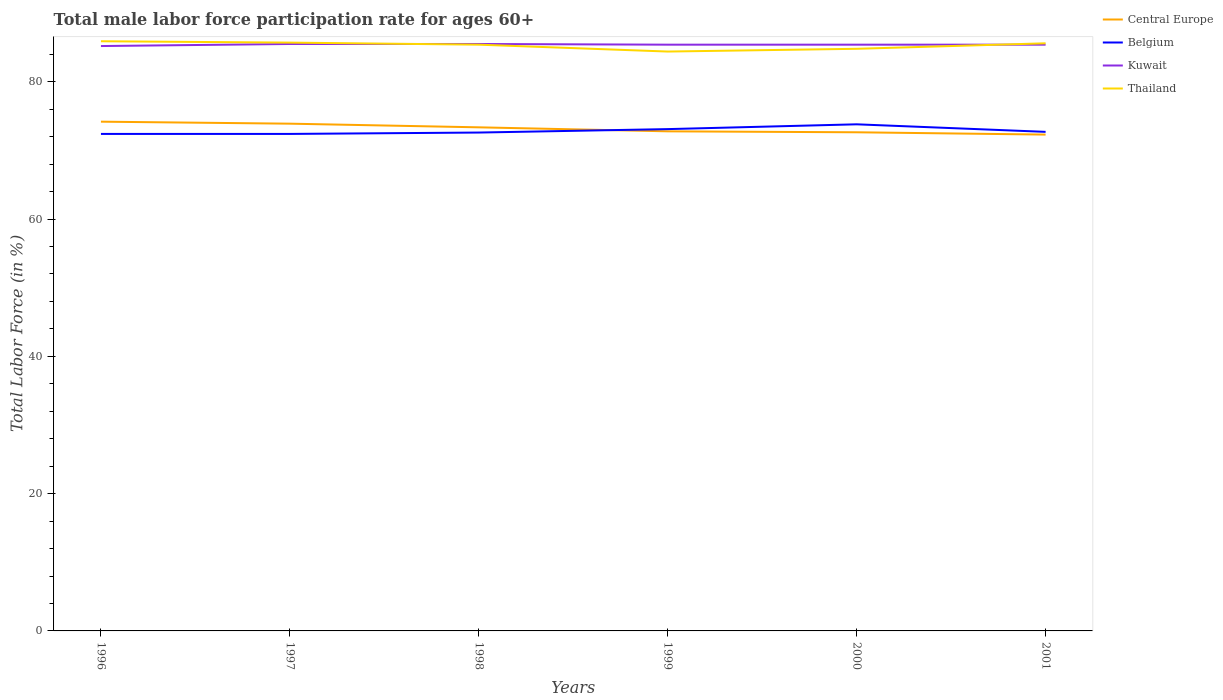How many different coloured lines are there?
Provide a short and direct response. 4. Across all years, what is the maximum male labor force participation rate in Kuwait?
Your answer should be compact. 85.2. In which year was the male labor force participation rate in Kuwait maximum?
Your answer should be very brief. 1996. What is the total male labor force participation rate in Central Europe in the graph?
Your answer should be very brief. 0.14. What is the difference between the highest and the second highest male labor force participation rate in Central Europe?
Your answer should be very brief. 1.88. Is the male labor force participation rate in Central Europe strictly greater than the male labor force participation rate in Kuwait over the years?
Ensure brevity in your answer.  Yes. Are the values on the major ticks of Y-axis written in scientific E-notation?
Your response must be concise. No. Does the graph contain any zero values?
Give a very brief answer. No. Does the graph contain grids?
Provide a short and direct response. No. How many legend labels are there?
Keep it short and to the point. 4. How are the legend labels stacked?
Provide a succinct answer. Vertical. What is the title of the graph?
Your response must be concise. Total male labor force participation rate for ages 60+. Does "Greece" appear as one of the legend labels in the graph?
Provide a succinct answer. No. What is the label or title of the X-axis?
Give a very brief answer. Years. What is the label or title of the Y-axis?
Give a very brief answer. Total Labor Force (in %). What is the Total Labor Force (in %) in Central Europe in 1996?
Keep it short and to the point. 74.18. What is the Total Labor Force (in %) in Belgium in 1996?
Provide a succinct answer. 72.4. What is the Total Labor Force (in %) in Kuwait in 1996?
Offer a terse response. 85.2. What is the Total Labor Force (in %) of Thailand in 1996?
Keep it short and to the point. 85.9. What is the Total Labor Force (in %) of Central Europe in 1997?
Your answer should be compact. 73.89. What is the Total Labor Force (in %) in Belgium in 1997?
Keep it short and to the point. 72.4. What is the Total Labor Force (in %) in Kuwait in 1997?
Ensure brevity in your answer.  85.5. What is the Total Labor Force (in %) of Thailand in 1997?
Provide a short and direct response. 85.7. What is the Total Labor Force (in %) in Central Europe in 1998?
Offer a very short reply. 73.36. What is the Total Labor Force (in %) of Belgium in 1998?
Keep it short and to the point. 72.6. What is the Total Labor Force (in %) in Kuwait in 1998?
Your answer should be compact. 85.5. What is the Total Labor Force (in %) of Thailand in 1998?
Offer a terse response. 85.4. What is the Total Labor Force (in %) in Central Europe in 1999?
Make the answer very short. 72.78. What is the Total Labor Force (in %) of Belgium in 1999?
Ensure brevity in your answer.  73.1. What is the Total Labor Force (in %) in Kuwait in 1999?
Give a very brief answer. 85.4. What is the Total Labor Force (in %) of Thailand in 1999?
Provide a short and direct response. 84.4. What is the Total Labor Force (in %) in Central Europe in 2000?
Give a very brief answer. 72.64. What is the Total Labor Force (in %) of Belgium in 2000?
Your response must be concise. 73.8. What is the Total Labor Force (in %) of Kuwait in 2000?
Ensure brevity in your answer.  85.4. What is the Total Labor Force (in %) of Thailand in 2000?
Your answer should be very brief. 84.8. What is the Total Labor Force (in %) in Central Europe in 2001?
Your answer should be very brief. 72.3. What is the Total Labor Force (in %) in Belgium in 2001?
Your answer should be compact. 72.7. What is the Total Labor Force (in %) of Kuwait in 2001?
Your answer should be very brief. 85.4. What is the Total Labor Force (in %) in Thailand in 2001?
Offer a very short reply. 85.6. Across all years, what is the maximum Total Labor Force (in %) in Central Europe?
Ensure brevity in your answer.  74.18. Across all years, what is the maximum Total Labor Force (in %) in Belgium?
Offer a very short reply. 73.8. Across all years, what is the maximum Total Labor Force (in %) of Kuwait?
Keep it short and to the point. 85.5. Across all years, what is the maximum Total Labor Force (in %) in Thailand?
Offer a terse response. 85.9. Across all years, what is the minimum Total Labor Force (in %) of Central Europe?
Offer a very short reply. 72.3. Across all years, what is the minimum Total Labor Force (in %) in Belgium?
Give a very brief answer. 72.4. Across all years, what is the minimum Total Labor Force (in %) of Kuwait?
Offer a very short reply. 85.2. Across all years, what is the minimum Total Labor Force (in %) in Thailand?
Your answer should be very brief. 84.4. What is the total Total Labor Force (in %) of Central Europe in the graph?
Offer a very short reply. 439.15. What is the total Total Labor Force (in %) of Belgium in the graph?
Your response must be concise. 437. What is the total Total Labor Force (in %) of Kuwait in the graph?
Give a very brief answer. 512.4. What is the total Total Labor Force (in %) in Thailand in the graph?
Your answer should be very brief. 511.8. What is the difference between the Total Labor Force (in %) in Central Europe in 1996 and that in 1997?
Provide a succinct answer. 0.29. What is the difference between the Total Labor Force (in %) in Central Europe in 1996 and that in 1998?
Offer a terse response. 0.82. What is the difference between the Total Labor Force (in %) in Belgium in 1996 and that in 1998?
Your answer should be compact. -0.2. What is the difference between the Total Labor Force (in %) of Thailand in 1996 and that in 1998?
Your answer should be compact. 0.5. What is the difference between the Total Labor Force (in %) of Central Europe in 1996 and that in 1999?
Your answer should be very brief. 1.41. What is the difference between the Total Labor Force (in %) of Belgium in 1996 and that in 1999?
Offer a terse response. -0.7. What is the difference between the Total Labor Force (in %) in Central Europe in 1996 and that in 2000?
Your answer should be very brief. 1.54. What is the difference between the Total Labor Force (in %) of Belgium in 1996 and that in 2000?
Make the answer very short. -1.4. What is the difference between the Total Labor Force (in %) in Thailand in 1996 and that in 2000?
Give a very brief answer. 1.1. What is the difference between the Total Labor Force (in %) in Central Europe in 1996 and that in 2001?
Provide a succinct answer. 1.88. What is the difference between the Total Labor Force (in %) of Belgium in 1996 and that in 2001?
Offer a terse response. -0.3. What is the difference between the Total Labor Force (in %) of Kuwait in 1996 and that in 2001?
Provide a succinct answer. -0.2. What is the difference between the Total Labor Force (in %) in Central Europe in 1997 and that in 1998?
Your answer should be very brief. 0.53. What is the difference between the Total Labor Force (in %) in Kuwait in 1997 and that in 1998?
Keep it short and to the point. 0. What is the difference between the Total Labor Force (in %) in Thailand in 1997 and that in 1998?
Your answer should be compact. 0.3. What is the difference between the Total Labor Force (in %) of Central Europe in 1997 and that in 1999?
Offer a terse response. 1.11. What is the difference between the Total Labor Force (in %) of Belgium in 1997 and that in 1999?
Make the answer very short. -0.7. What is the difference between the Total Labor Force (in %) of Central Europe in 1997 and that in 2000?
Provide a succinct answer. 1.25. What is the difference between the Total Labor Force (in %) in Belgium in 1997 and that in 2000?
Offer a terse response. -1.4. What is the difference between the Total Labor Force (in %) of Kuwait in 1997 and that in 2000?
Offer a terse response. 0.1. What is the difference between the Total Labor Force (in %) of Thailand in 1997 and that in 2000?
Provide a succinct answer. 0.9. What is the difference between the Total Labor Force (in %) of Central Europe in 1997 and that in 2001?
Your answer should be very brief. 1.59. What is the difference between the Total Labor Force (in %) of Belgium in 1997 and that in 2001?
Your answer should be very brief. -0.3. What is the difference between the Total Labor Force (in %) in Kuwait in 1997 and that in 2001?
Make the answer very short. 0.1. What is the difference between the Total Labor Force (in %) in Thailand in 1997 and that in 2001?
Your answer should be very brief. 0.1. What is the difference between the Total Labor Force (in %) in Central Europe in 1998 and that in 1999?
Give a very brief answer. 0.58. What is the difference between the Total Labor Force (in %) of Thailand in 1998 and that in 1999?
Offer a terse response. 1. What is the difference between the Total Labor Force (in %) in Central Europe in 1998 and that in 2000?
Offer a very short reply. 0.72. What is the difference between the Total Labor Force (in %) in Belgium in 1998 and that in 2000?
Provide a succinct answer. -1.2. What is the difference between the Total Labor Force (in %) of Central Europe in 1998 and that in 2001?
Provide a succinct answer. 1.06. What is the difference between the Total Labor Force (in %) in Belgium in 1998 and that in 2001?
Make the answer very short. -0.1. What is the difference between the Total Labor Force (in %) in Kuwait in 1998 and that in 2001?
Provide a short and direct response. 0.1. What is the difference between the Total Labor Force (in %) of Thailand in 1998 and that in 2001?
Give a very brief answer. -0.2. What is the difference between the Total Labor Force (in %) of Central Europe in 1999 and that in 2000?
Offer a terse response. 0.14. What is the difference between the Total Labor Force (in %) of Kuwait in 1999 and that in 2000?
Give a very brief answer. 0. What is the difference between the Total Labor Force (in %) of Central Europe in 1999 and that in 2001?
Provide a short and direct response. 0.48. What is the difference between the Total Labor Force (in %) in Belgium in 1999 and that in 2001?
Ensure brevity in your answer.  0.4. What is the difference between the Total Labor Force (in %) in Thailand in 1999 and that in 2001?
Offer a terse response. -1.2. What is the difference between the Total Labor Force (in %) of Central Europe in 2000 and that in 2001?
Your answer should be compact. 0.34. What is the difference between the Total Labor Force (in %) of Belgium in 2000 and that in 2001?
Offer a terse response. 1.1. What is the difference between the Total Labor Force (in %) of Central Europe in 1996 and the Total Labor Force (in %) of Belgium in 1997?
Your answer should be very brief. 1.78. What is the difference between the Total Labor Force (in %) in Central Europe in 1996 and the Total Labor Force (in %) in Kuwait in 1997?
Make the answer very short. -11.32. What is the difference between the Total Labor Force (in %) of Central Europe in 1996 and the Total Labor Force (in %) of Thailand in 1997?
Your response must be concise. -11.52. What is the difference between the Total Labor Force (in %) of Kuwait in 1996 and the Total Labor Force (in %) of Thailand in 1997?
Offer a terse response. -0.5. What is the difference between the Total Labor Force (in %) of Central Europe in 1996 and the Total Labor Force (in %) of Belgium in 1998?
Provide a short and direct response. 1.58. What is the difference between the Total Labor Force (in %) in Central Europe in 1996 and the Total Labor Force (in %) in Kuwait in 1998?
Give a very brief answer. -11.32. What is the difference between the Total Labor Force (in %) in Central Europe in 1996 and the Total Labor Force (in %) in Thailand in 1998?
Ensure brevity in your answer.  -11.22. What is the difference between the Total Labor Force (in %) in Belgium in 1996 and the Total Labor Force (in %) in Kuwait in 1998?
Make the answer very short. -13.1. What is the difference between the Total Labor Force (in %) of Central Europe in 1996 and the Total Labor Force (in %) of Belgium in 1999?
Your answer should be compact. 1.08. What is the difference between the Total Labor Force (in %) in Central Europe in 1996 and the Total Labor Force (in %) in Kuwait in 1999?
Provide a short and direct response. -11.22. What is the difference between the Total Labor Force (in %) in Central Europe in 1996 and the Total Labor Force (in %) in Thailand in 1999?
Offer a very short reply. -10.22. What is the difference between the Total Labor Force (in %) of Kuwait in 1996 and the Total Labor Force (in %) of Thailand in 1999?
Offer a very short reply. 0.8. What is the difference between the Total Labor Force (in %) in Central Europe in 1996 and the Total Labor Force (in %) in Belgium in 2000?
Your answer should be compact. 0.38. What is the difference between the Total Labor Force (in %) of Central Europe in 1996 and the Total Labor Force (in %) of Kuwait in 2000?
Provide a succinct answer. -11.22. What is the difference between the Total Labor Force (in %) in Central Europe in 1996 and the Total Labor Force (in %) in Thailand in 2000?
Provide a succinct answer. -10.62. What is the difference between the Total Labor Force (in %) of Belgium in 1996 and the Total Labor Force (in %) of Kuwait in 2000?
Ensure brevity in your answer.  -13. What is the difference between the Total Labor Force (in %) of Central Europe in 1996 and the Total Labor Force (in %) of Belgium in 2001?
Offer a terse response. 1.48. What is the difference between the Total Labor Force (in %) in Central Europe in 1996 and the Total Labor Force (in %) in Kuwait in 2001?
Offer a very short reply. -11.22. What is the difference between the Total Labor Force (in %) in Central Europe in 1996 and the Total Labor Force (in %) in Thailand in 2001?
Offer a terse response. -11.42. What is the difference between the Total Labor Force (in %) in Belgium in 1996 and the Total Labor Force (in %) in Kuwait in 2001?
Ensure brevity in your answer.  -13. What is the difference between the Total Labor Force (in %) of Kuwait in 1996 and the Total Labor Force (in %) of Thailand in 2001?
Offer a terse response. -0.4. What is the difference between the Total Labor Force (in %) in Central Europe in 1997 and the Total Labor Force (in %) in Belgium in 1998?
Your answer should be compact. 1.29. What is the difference between the Total Labor Force (in %) in Central Europe in 1997 and the Total Labor Force (in %) in Kuwait in 1998?
Keep it short and to the point. -11.61. What is the difference between the Total Labor Force (in %) in Central Europe in 1997 and the Total Labor Force (in %) in Thailand in 1998?
Offer a very short reply. -11.51. What is the difference between the Total Labor Force (in %) in Belgium in 1997 and the Total Labor Force (in %) in Thailand in 1998?
Ensure brevity in your answer.  -13. What is the difference between the Total Labor Force (in %) in Central Europe in 1997 and the Total Labor Force (in %) in Belgium in 1999?
Your response must be concise. 0.79. What is the difference between the Total Labor Force (in %) of Central Europe in 1997 and the Total Labor Force (in %) of Kuwait in 1999?
Keep it short and to the point. -11.51. What is the difference between the Total Labor Force (in %) of Central Europe in 1997 and the Total Labor Force (in %) of Thailand in 1999?
Your answer should be compact. -10.51. What is the difference between the Total Labor Force (in %) in Belgium in 1997 and the Total Labor Force (in %) in Thailand in 1999?
Make the answer very short. -12. What is the difference between the Total Labor Force (in %) of Central Europe in 1997 and the Total Labor Force (in %) of Belgium in 2000?
Your response must be concise. 0.09. What is the difference between the Total Labor Force (in %) in Central Europe in 1997 and the Total Labor Force (in %) in Kuwait in 2000?
Provide a succinct answer. -11.51. What is the difference between the Total Labor Force (in %) of Central Europe in 1997 and the Total Labor Force (in %) of Thailand in 2000?
Provide a short and direct response. -10.91. What is the difference between the Total Labor Force (in %) in Belgium in 1997 and the Total Labor Force (in %) in Kuwait in 2000?
Provide a short and direct response. -13. What is the difference between the Total Labor Force (in %) in Belgium in 1997 and the Total Labor Force (in %) in Thailand in 2000?
Make the answer very short. -12.4. What is the difference between the Total Labor Force (in %) of Central Europe in 1997 and the Total Labor Force (in %) of Belgium in 2001?
Ensure brevity in your answer.  1.19. What is the difference between the Total Labor Force (in %) in Central Europe in 1997 and the Total Labor Force (in %) in Kuwait in 2001?
Provide a succinct answer. -11.51. What is the difference between the Total Labor Force (in %) in Central Europe in 1997 and the Total Labor Force (in %) in Thailand in 2001?
Give a very brief answer. -11.71. What is the difference between the Total Labor Force (in %) in Central Europe in 1998 and the Total Labor Force (in %) in Belgium in 1999?
Give a very brief answer. 0.26. What is the difference between the Total Labor Force (in %) in Central Europe in 1998 and the Total Labor Force (in %) in Kuwait in 1999?
Your answer should be very brief. -12.04. What is the difference between the Total Labor Force (in %) in Central Europe in 1998 and the Total Labor Force (in %) in Thailand in 1999?
Ensure brevity in your answer.  -11.04. What is the difference between the Total Labor Force (in %) in Belgium in 1998 and the Total Labor Force (in %) in Kuwait in 1999?
Offer a very short reply. -12.8. What is the difference between the Total Labor Force (in %) in Belgium in 1998 and the Total Labor Force (in %) in Thailand in 1999?
Provide a succinct answer. -11.8. What is the difference between the Total Labor Force (in %) of Central Europe in 1998 and the Total Labor Force (in %) of Belgium in 2000?
Provide a succinct answer. -0.44. What is the difference between the Total Labor Force (in %) of Central Europe in 1998 and the Total Labor Force (in %) of Kuwait in 2000?
Your answer should be very brief. -12.04. What is the difference between the Total Labor Force (in %) of Central Europe in 1998 and the Total Labor Force (in %) of Thailand in 2000?
Keep it short and to the point. -11.44. What is the difference between the Total Labor Force (in %) in Belgium in 1998 and the Total Labor Force (in %) in Thailand in 2000?
Provide a short and direct response. -12.2. What is the difference between the Total Labor Force (in %) of Kuwait in 1998 and the Total Labor Force (in %) of Thailand in 2000?
Your answer should be very brief. 0.7. What is the difference between the Total Labor Force (in %) in Central Europe in 1998 and the Total Labor Force (in %) in Belgium in 2001?
Make the answer very short. 0.66. What is the difference between the Total Labor Force (in %) of Central Europe in 1998 and the Total Labor Force (in %) of Kuwait in 2001?
Your response must be concise. -12.04. What is the difference between the Total Labor Force (in %) of Central Europe in 1998 and the Total Labor Force (in %) of Thailand in 2001?
Your answer should be very brief. -12.24. What is the difference between the Total Labor Force (in %) of Belgium in 1998 and the Total Labor Force (in %) of Kuwait in 2001?
Give a very brief answer. -12.8. What is the difference between the Total Labor Force (in %) of Belgium in 1998 and the Total Labor Force (in %) of Thailand in 2001?
Your response must be concise. -13. What is the difference between the Total Labor Force (in %) in Kuwait in 1998 and the Total Labor Force (in %) in Thailand in 2001?
Make the answer very short. -0.1. What is the difference between the Total Labor Force (in %) of Central Europe in 1999 and the Total Labor Force (in %) of Belgium in 2000?
Your answer should be compact. -1.02. What is the difference between the Total Labor Force (in %) of Central Europe in 1999 and the Total Labor Force (in %) of Kuwait in 2000?
Provide a short and direct response. -12.62. What is the difference between the Total Labor Force (in %) in Central Europe in 1999 and the Total Labor Force (in %) in Thailand in 2000?
Your response must be concise. -12.02. What is the difference between the Total Labor Force (in %) of Belgium in 1999 and the Total Labor Force (in %) of Kuwait in 2000?
Ensure brevity in your answer.  -12.3. What is the difference between the Total Labor Force (in %) in Kuwait in 1999 and the Total Labor Force (in %) in Thailand in 2000?
Offer a terse response. 0.6. What is the difference between the Total Labor Force (in %) in Central Europe in 1999 and the Total Labor Force (in %) in Belgium in 2001?
Your response must be concise. 0.08. What is the difference between the Total Labor Force (in %) of Central Europe in 1999 and the Total Labor Force (in %) of Kuwait in 2001?
Make the answer very short. -12.62. What is the difference between the Total Labor Force (in %) in Central Europe in 1999 and the Total Labor Force (in %) in Thailand in 2001?
Your answer should be compact. -12.82. What is the difference between the Total Labor Force (in %) of Central Europe in 2000 and the Total Labor Force (in %) of Belgium in 2001?
Make the answer very short. -0.06. What is the difference between the Total Labor Force (in %) of Central Europe in 2000 and the Total Labor Force (in %) of Kuwait in 2001?
Provide a succinct answer. -12.76. What is the difference between the Total Labor Force (in %) in Central Europe in 2000 and the Total Labor Force (in %) in Thailand in 2001?
Your response must be concise. -12.96. What is the difference between the Total Labor Force (in %) in Belgium in 2000 and the Total Labor Force (in %) in Kuwait in 2001?
Keep it short and to the point. -11.6. What is the difference between the Total Labor Force (in %) in Kuwait in 2000 and the Total Labor Force (in %) in Thailand in 2001?
Keep it short and to the point. -0.2. What is the average Total Labor Force (in %) of Central Europe per year?
Your answer should be compact. 73.19. What is the average Total Labor Force (in %) in Belgium per year?
Your answer should be very brief. 72.83. What is the average Total Labor Force (in %) of Kuwait per year?
Provide a short and direct response. 85.4. What is the average Total Labor Force (in %) of Thailand per year?
Make the answer very short. 85.3. In the year 1996, what is the difference between the Total Labor Force (in %) of Central Europe and Total Labor Force (in %) of Belgium?
Give a very brief answer. 1.78. In the year 1996, what is the difference between the Total Labor Force (in %) of Central Europe and Total Labor Force (in %) of Kuwait?
Your answer should be very brief. -11.02. In the year 1996, what is the difference between the Total Labor Force (in %) in Central Europe and Total Labor Force (in %) in Thailand?
Offer a very short reply. -11.72. In the year 1996, what is the difference between the Total Labor Force (in %) of Belgium and Total Labor Force (in %) of Kuwait?
Make the answer very short. -12.8. In the year 1996, what is the difference between the Total Labor Force (in %) of Kuwait and Total Labor Force (in %) of Thailand?
Your answer should be very brief. -0.7. In the year 1997, what is the difference between the Total Labor Force (in %) in Central Europe and Total Labor Force (in %) in Belgium?
Give a very brief answer. 1.49. In the year 1997, what is the difference between the Total Labor Force (in %) in Central Europe and Total Labor Force (in %) in Kuwait?
Offer a terse response. -11.61. In the year 1997, what is the difference between the Total Labor Force (in %) in Central Europe and Total Labor Force (in %) in Thailand?
Your answer should be compact. -11.81. In the year 1997, what is the difference between the Total Labor Force (in %) of Belgium and Total Labor Force (in %) of Kuwait?
Provide a succinct answer. -13.1. In the year 1997, what is the difference between the Total Labor Force (in %) of Belgium and Total Labor Force (in %) of Thailand?
Your answer should be compact. -13.3. In the year 1997, what is the difference between the Total Labor Force (in %) in Kuwait and Total Labor Force (in %) in Thailand?
Provide a short and direct response. -0.2. In the year 1998, what is the difference between the Total Labor Force (in %) in Central Europe and Total Labor Force (in %) in Belgium?
Keep it short and to the point. 0.76. In the year 1998, what is the difference between the Total Labor Force (in %) of Central Europe and Total Labor Force (in %) of Kuwait?
Your response must be concise. -12.14. In the year 1998, what is the difference between the Total Labor Force (in %) in Central Europe and Total Labor Force (in %) in Thailand?
Give a very brief answer. -12.04. In the year 1999, what is the difference between the Total Labor Force (in %) in Central Europe and Total Labor Force (in %) in Belgium?
Your response must be concise. -0.32. In the year 1999, what is the difference between the Total Labor Force (in %) in Central Europe and Total Labor Force (in %) in Kuwait?
Offer a very short reply. -12.62. In the year 1999, what is the difference between the Total Labor Force (in %) of Central Europe and Total Labor Force (in %) of Thailand?
Offer a very short reply. -11.62. In the year 2000, what is the difference between the Total Labor Force (in %) in Central Europe and Total Labor Force (in %) in Belgium?
Your answer should be compact. -1.16. In the year 2000, what is the difference between the Total Labor Force (in %) in Central Europe and Total Labor Force (in %) in Kuwait?
Provide a succinct answer. -12.76. In the year 2000, what is the difference between the Total Labor Force (in %) of Central Europe and Total Labor Force (in %) of Thailand?
Ensure brevity in your answer.  -12.16. In the year 2000, what is the difference between the Total Labor Force (in %) in Belgium and Total Labor Force (in %) in Thailand?
Keep it short and to the point. -11. In the year 2001, what is the difference between the Total Labor Force (in %) of Central Europe and Total Labor Force (in %) of Belgium?
Your response must be concise. -0.4. In the year 2001, what is the difference between the Total Labor Force (in %) of Central Europe and Total Labor Force (in %) of Kuwait?
Your answer should be compact. -13.1. In the year 2001, what is the difference between the Total Labor Force (in %) of Central Europe and Total Labor Force (in %) of Thailand?
Give a very brief answer. -13.3. In the year 2001, what is the difference between the Total Labor Force (in %) in Belgium and Total Labor Force (in %) in Thailand?
Ensure brevity in your answer.  -12.9. In the year 2001, what is the difference between the Total Labor Force (in %) in Kuwait and Total Labor Force (in %) in Thailand?
Offer a terse response. -0.2. What is the ratio of the Total Labor Force (in %) of Thailand in 1996 to that in 1997?
Provide a short and direct response. 1. What is the ratio of the Total Labor Force (in %) in Central Europe in 1996 to that in 1998?
Offer a terse response. 1.01. What is the ratio of the Total Labor Force (in %) of Belgium in 1996 to that in 1998?
Offer a terse response. 1. What is the ratio of the Total Labor Force (in %) of Thailand in 1996 to that in 1998?
Keep it short and to the point. 1.01. What is the ratio of the Total Labor Force (in %) of Central Europe in 1996 to that in 1999?
Provide a succinct answer. 1.02. What is the ratio of the Total Labor Force (in %) of Belgium in 1996 to that in 1999?
Your response must be concise. 0.99. What is the ratio of the Total Labor Force (in %) in Thailand in 1996 to that in 1999?
Offer a very short reply. 1.02. What is the ratio of the Total Labor Force (in %) of Central Europe in 1996 to that in 2000?
Keep it short and to the point. 1.02. What is the ratio of the Total Labor Force (in %) in Central Europe in 1996 to that in 2001?
Give a very brief answer. 1.03. What is the ratio of the Total Labor Force (in %) of Belgium in 1996 to that in 2001?
Make the answer very short. 1. What is the ratio of the Total Labor Force (in %) in Thailand in 1996 to that in 2001?
Make the answer very short. 1. What is the ratio of the Total Labor Force (in %) of Central Europe in 1997 to that in 1998?
Keep it short and to the point. 1.01. What is the ratio of the Total Labor Force (in %) of Central Europe in 1997 to that in 1999?
Offer a very short reply. 1.02. What is the ratio of the Total Labor Force (in %) of Kuwait in 1997 to that in 1999?
Make the answer very short. 1. What is the ratio of the Total Labor Force (in %) of Thailand in 1997 to that in 1999?
Ensure brevity in your answer.  1.02. What is the ratio of the Total Labor Force (in %) of Central Europe in 1997 to that in 2000?
Provide a succinct answer. 1.02. What is the ratio of the Total Labor Force (in %) in Belgium in 1997 to that in 2000?
Provide a short and direct response. 0.98. What is the ratio of the Total Labor Force (in %) of Thailand in 1997 to that in 2000?
Provide a succinct answer. 1.01. What is the ratio of the Total Labor Force (in %) of Kuwait in 1997 to that in 2001?
Keep it short and to the point. 1. What is the ratio of the Total Labor Force (in %) of Thailand in 1997 to that in 2001?
Offer a very short reply. 1. What is the ratio of the Total Labor Force (in %) of Central Europe in 1998 to that in 1999?
Your answer should be very brief. 1.01. What is the ratio of the Total Labor Force (in %) in Kuwait in 1998 to that in 1999?
Make the answer very short. 1. What is the ratio of the Total Labor Force (in %) in Thailand in 1998 to that in 1999?
Your answer should be compact. 1.01. What is the ratio of the Total Labor Force (in %) of Central Europe in 1998 to that in 2000?
Your response must be concise. 1.01. What is the ratio of the Total Labor Force (in %) in Belgium in 1998 to that in 2000?
Provide a succinct answer. 0.98. What is the ratio of the Total Labor Force (in %) of Thailand in 1998 to that in 2000?
Keep it short and to the point. 1.01. What is the ratio of the Total Labor Force (in %) of Central Europe in 1998 to that in 2001?
Your response must be concise. 1.01. What is the ratio of the Total Labor Force (in %) of Kuwait in 1998 to that in 2001?
Your answer should be very brief. 1. What is the ratio of the Total Labor Force (in %) of Central Europe in 1999 to that in 2000?
Give a very brief answer. 1. What is the ratio of the Total Labor Force (in %) in Belgium in 1999 to that in 2000?
Ensure brevity in your answer.  0.99. What is the ratio of the Total Labor Force (in %) in Central Europe in 1999 to that in 2001?
Offer a terse response. 1.01. What is the ratio of the Total Labor Force (in %) in Belgium in 1999 to that in 2001?
Offer a very short reply. 1.01. What is the ratio of the Total Labor Force (in %) in Belgium in 2000 to that in 2001?
Keep it short and to the point. 1.02. What is the ratio of the Total Labor Force (in %) of Kuwait in 2000 to that in 2001?
Provide a succinct answer. 1. What is the difference between the highest and the second highest Total Labor Force (in %) in Central Europe?
Make the answer very short. 0.29. What is the difference between the highest and the second highest Total Labor Force (in %) of Kuwait?
Give a very brief answer. 0. What is the difference between the highest and the lowest Total Labor Force (in %) of Central Europe?
Your answer should be very brief. 1.88. What is the difference between the highest and the lowest Total Labor Force (in %) in Kuwait?
Your response must be concise. 0.3. 